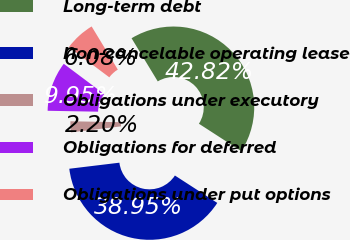<chart> <loc_0><loc_0><loc_500><loc_500><pie_chart><fcel>Long-term debt<fcel>Non-cancelable operating lease<fcel>Obligations under executory<fcel>Obligations for deferred<fcel>Obligations under put options<nl><fcel>42.82%<fcel>38.95%<fcel>2.2%<fcel>9.95%<fcel>6.08%<nl></chart> 